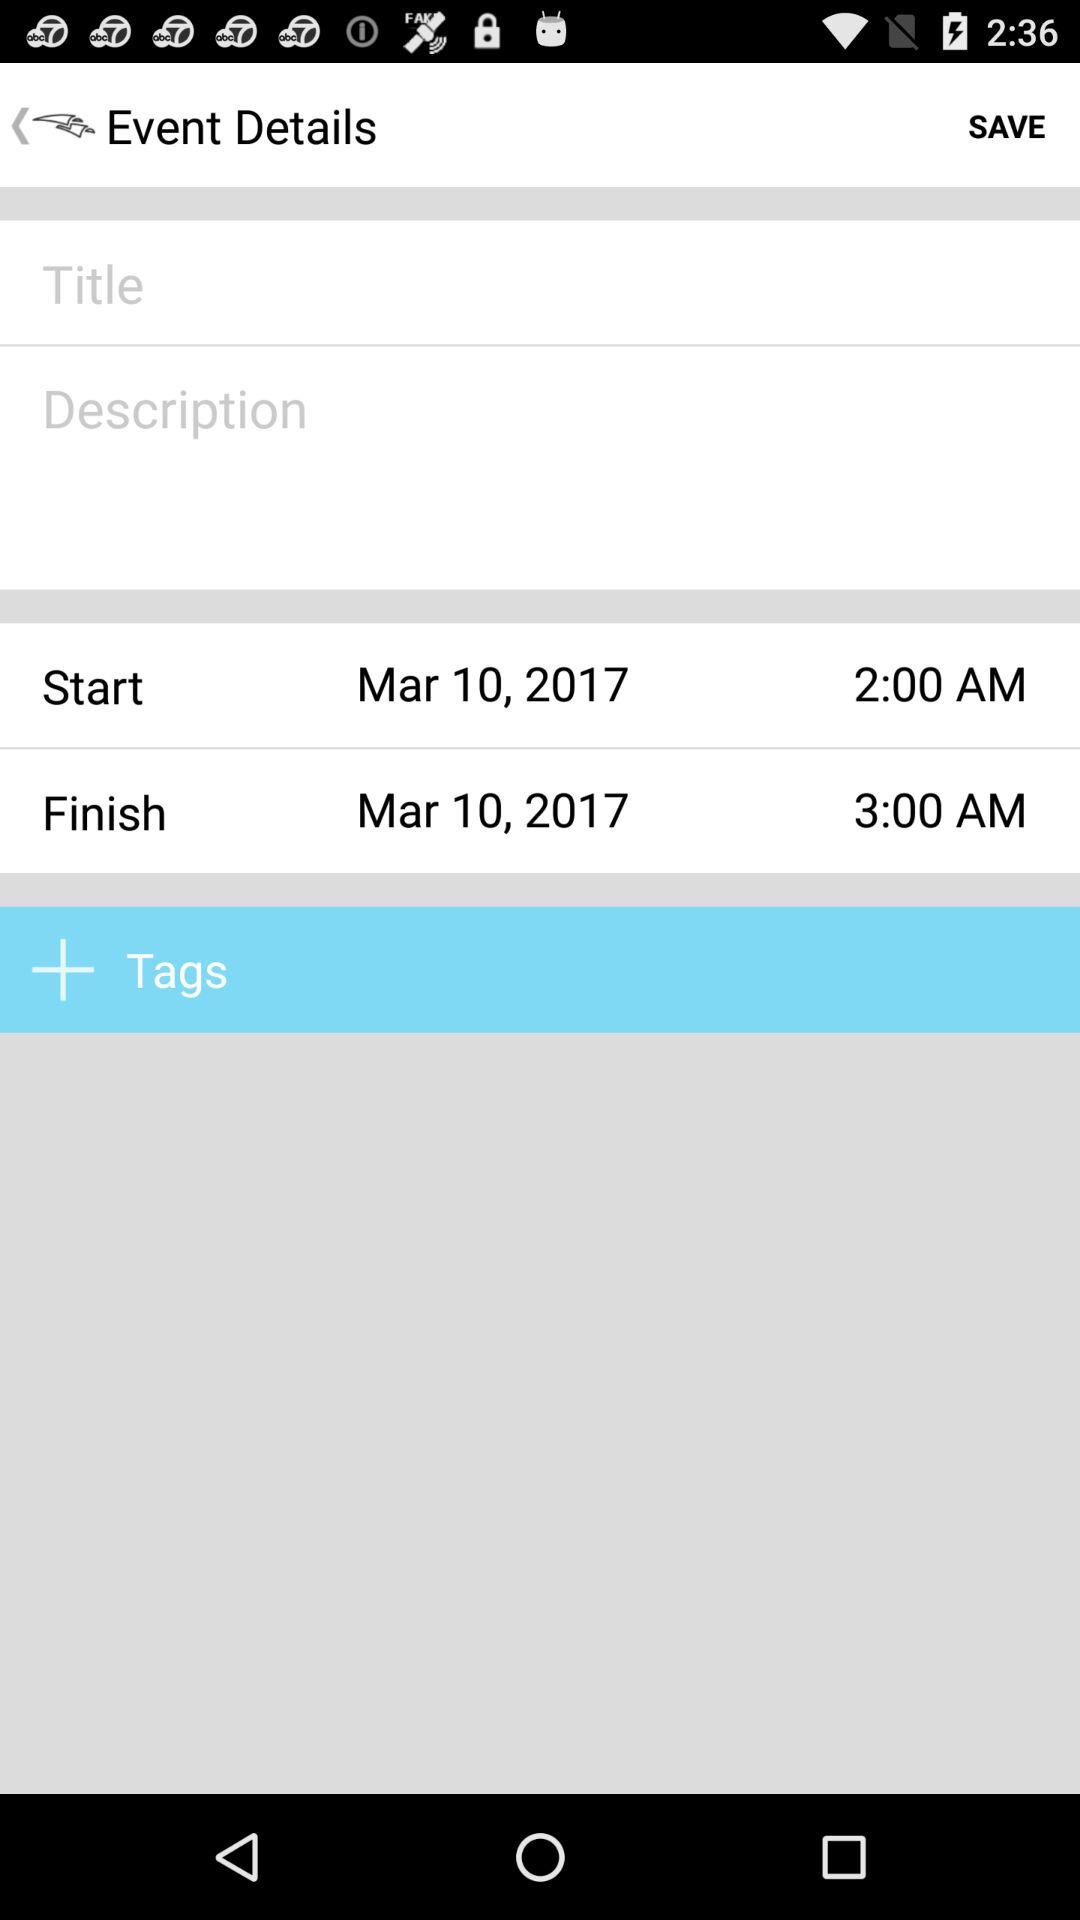What is the finish time? The finish time is 3 AM. 